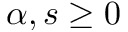<formula> <loc_0><loc_0><loc_500><loc_500>\alpha , s \geq 0</formula> 